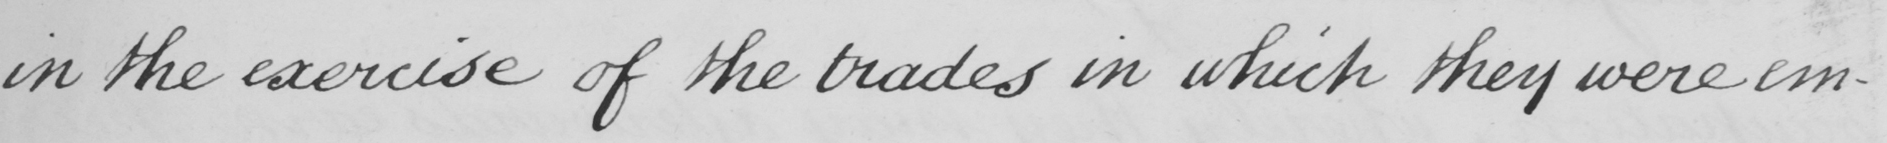What does this handwritten line say? in the exercise of the trades in which they were em- 